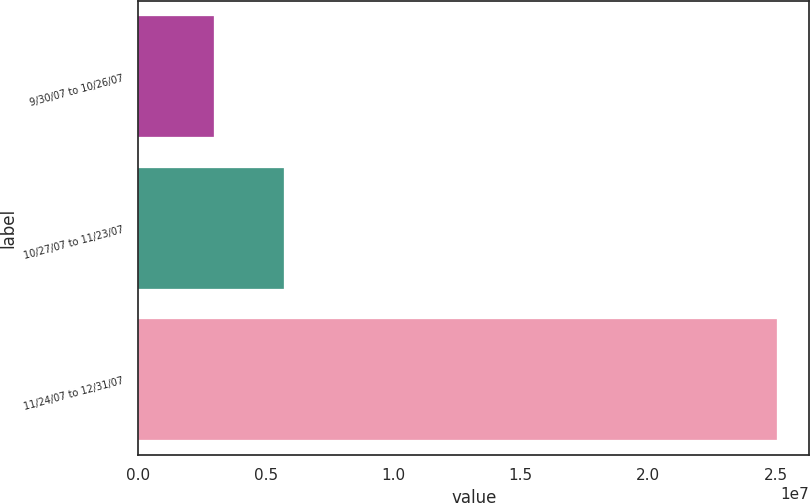Convert chart. <chart><loc_0><loc_0><loc_500><loc_500><bar_chart><fcel>9/30/07 to 10/26/07<fcel>10/27/07 to 11/23/07<fcel>11/24/07 to 12/31/07<nl><fcel>2.97295e+06<fcel>5.70992e+06<fcel>2.5064e+07<nl></chart> 